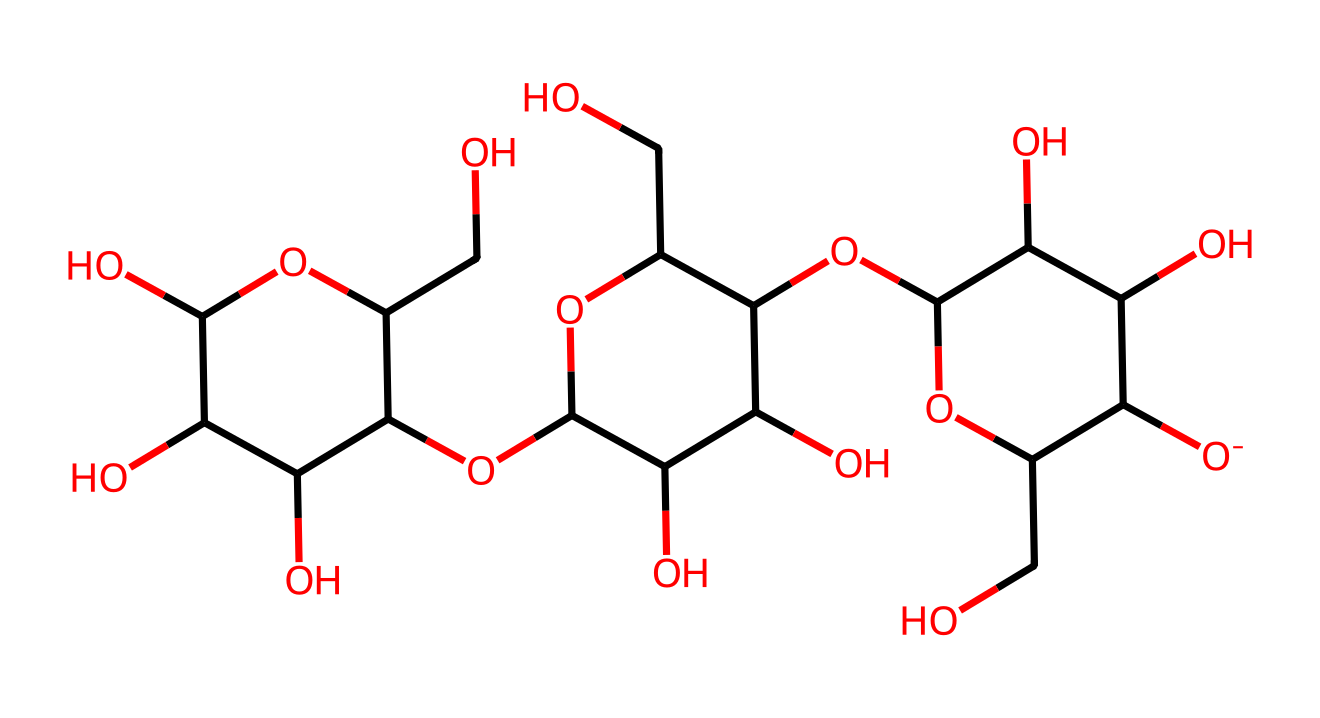What is the primary monomer unit in this polymer? The chemical structure indicates that cellulose is a polymer made up of glucose units. Each glucose subunit can be identified by the repeating hexagonal ring structure in the SMILES representation.
Answer: glucose How many oxygen atoms are present in the structure? By analyzing the SMILES representation, you can count the total number of oxygen atoms, which are represented as 'O' in the formula. In this case, there are 5 oxygen atoms.
Answer: 5 Does this polymer have branching in its structure? Upon examining the structure closely, it shows that the glucose units are connected in a linear fashion without branches, indicating that cellulose is unbranched.
Answer: no What functional groups are primarily present in cellulose? The SMILES notation reveals multiple hydroxyl (-OH) groups attached to the glucose rings, which are responsible for the solubility and reactivity of cellulose.
Answer: hydroxyl What type of glycosidic linkage connects the glucose units in cellulose? The analysis of the bonding in the chemical structure indicates that the glucose units are connected by β-1,4-glycosidic linkages, which is characteristic of cellulose.
Answer: beta-1,4 What is the degree of polymerization suggested by the structure? By counting the number of glucose units in the structure from the SMILES, we can estimate that there are several repeating glucose units, suggesting a high degree of polymerization typical of cellulose.
Answer: high How many carbon atoms are present in one monomer of cellulose? Each glucose unit, which is the monomer of cellulose, contains 6 carbon atoms, as indicated by the structural representation.
Answer: 6 